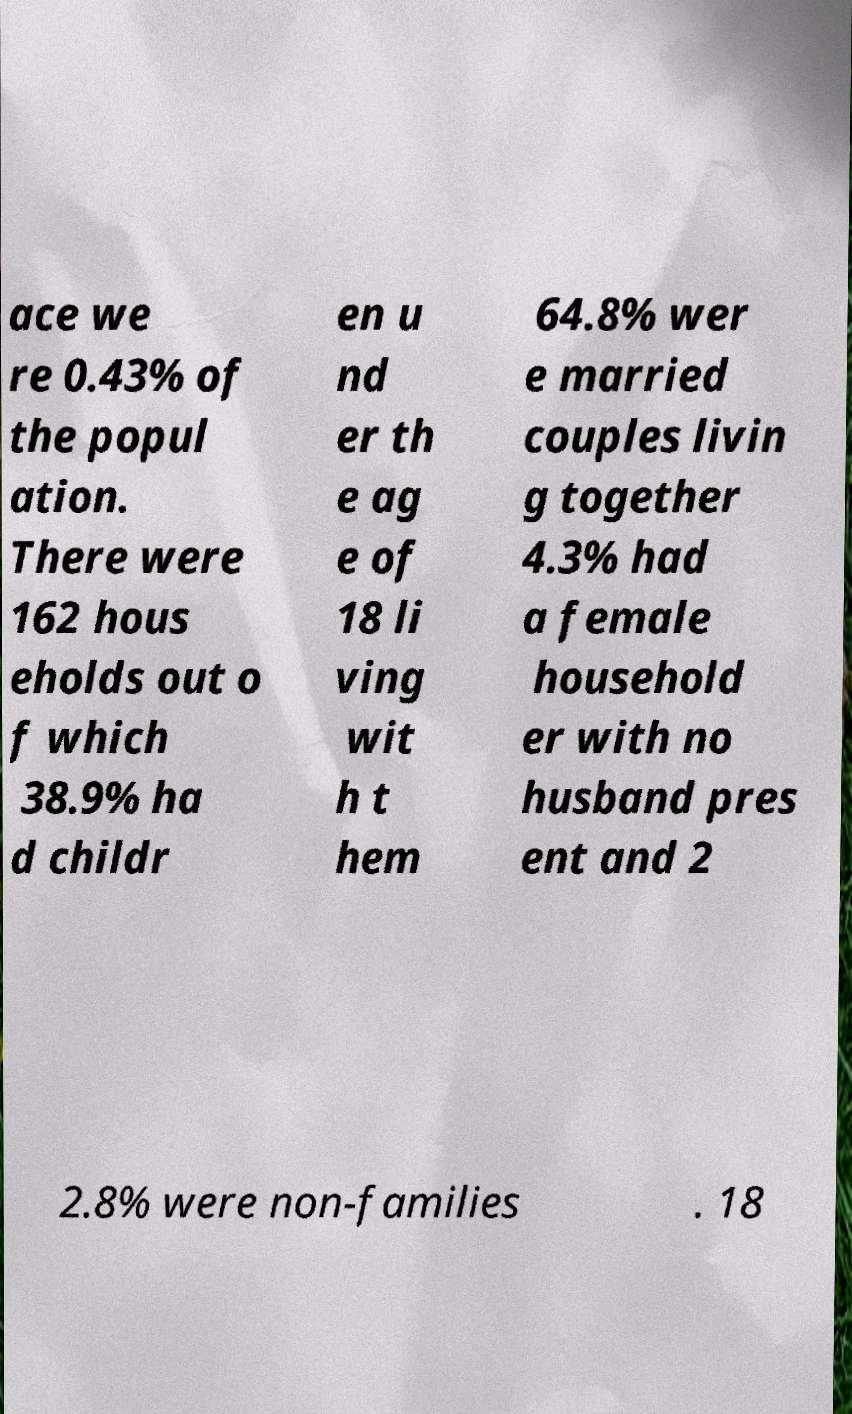Please read and relay the text visible in this image. What does it say? ace we re 0.43% of the popul ation. There were 162 hous eholds out o f which 38.9% ha d childr en u nd er th e ag e of 18 li ving wit h t hem 64.8% wer e married couples livin g together 4.3% had a female household er with no husband pres ent and 2 2.8% were non-families . 18 